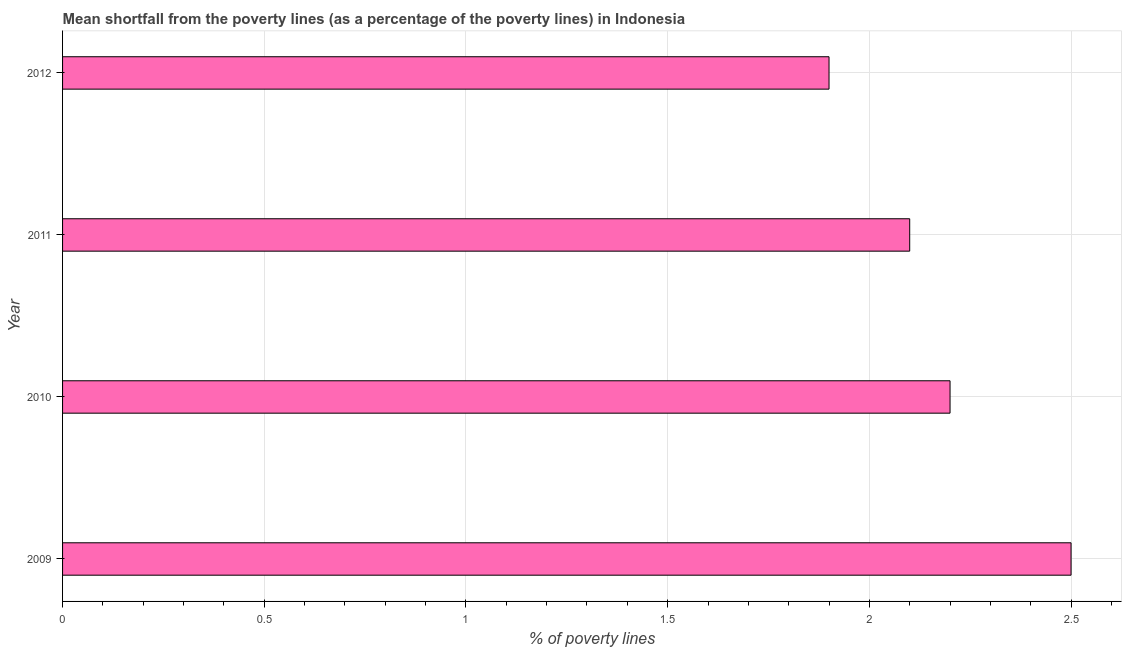Does the graph contain any zero values?
Provide a short and direct response. No. Does the graph contain grids?
Give a very brief answer. Yes. What is the title of the graph?
Ensure brevity in your answer.  Mean shortfall from the poverty lines (as a percentage of the poverty lines) in Indonesia. What is the label or title of the X-axis?
Your answer should be very brief. % of poverty lines. What is the label or title of the Y-axis?
Your response must be concise. Year. What is the poverty gap at national poverty lines in 2010?
Your response must be concise. 2.2. Across all years, what is the maximum poverty gap at national poverty lines?
Your answer should be compact. 2.5. Across all years, what is the minimum poverty gap at national poverty lines?
Offer a terse response. 1.9. What is the sum of the poverty gap at national poverty lines?
Ensure brevity in your answer.  8.7. What is the difference between the poverty gap at national poverty lines in 2010 and 2011?
Provide a succinct answer. 0.1. What is the average poverty gap at national poverty lines per year?
Offer a very short reply. 2.17. What is the median poverty gap at national poverty lines?
Your answer should be compact. 2.15. Do a majority of the years between 2009 and 2012 (inclusive) have poverty gap at national poverty lines greater than 1.3 %?
Provide a succinct answer. Yes. What is the ratio of the poverty gap at national poverty lines in 2010 to that in 2012?
Ensure brevity in your answer.  1.16. What is the difference between the highest and the second highest poverty gap at national poverty lines?
Your answer should be very brief. 0.3. Is the sum of the poverty gap at national poverty lines in 2010 and 2011 greater than the maximum poverty gap at national poverty lines across all years?
Offer a terse response. Yes. How many bars are there?
Make the answer very short. 4. Are all the bars in the graph horizontal?
Ensure brevity in your answer.  Yes. How many years are there in the graph?
Give a very brief answer. 4. What is the % of poverty lines in 2009?
Provide a succinct answer. 2.5. What is the % of poverty lines in 2011?
Keep it short and to the point. 2.1. What is the % of poverty lines in 2012?
Offer a terse response. 1.9. What is the difference between the % of poverty lines in 2009 and 2010?
Provide a succinct answer. 0.3. What is the difference between the % of poverty lines in 2009 and 2011?
Provide a succinct answer. 0.4. What is the ratio of the % of poverty lines in 2009 to that in 2010?
Provide a short and direct response. 1.14. What is the ratio of the % of poverty lines in 2009 to that in 2011?
Your answer should be compact. 1.19. What is the ratio of the % of poverty lines in 2009 to that in 2012?
Provide a short and direct response. 1.32. What is the ratio of the % of poverty lines in 2010 to that in 2011?
Your answer should be very brief. 1.05. What is the ratio of the % of poverty lines in 2010 to that in 2012?
Your answer should be very brief. 1.16. What is the ratio of the % of poverty lines in 2011 to that in 2012?
Provide a short and direct response. 1.1. 